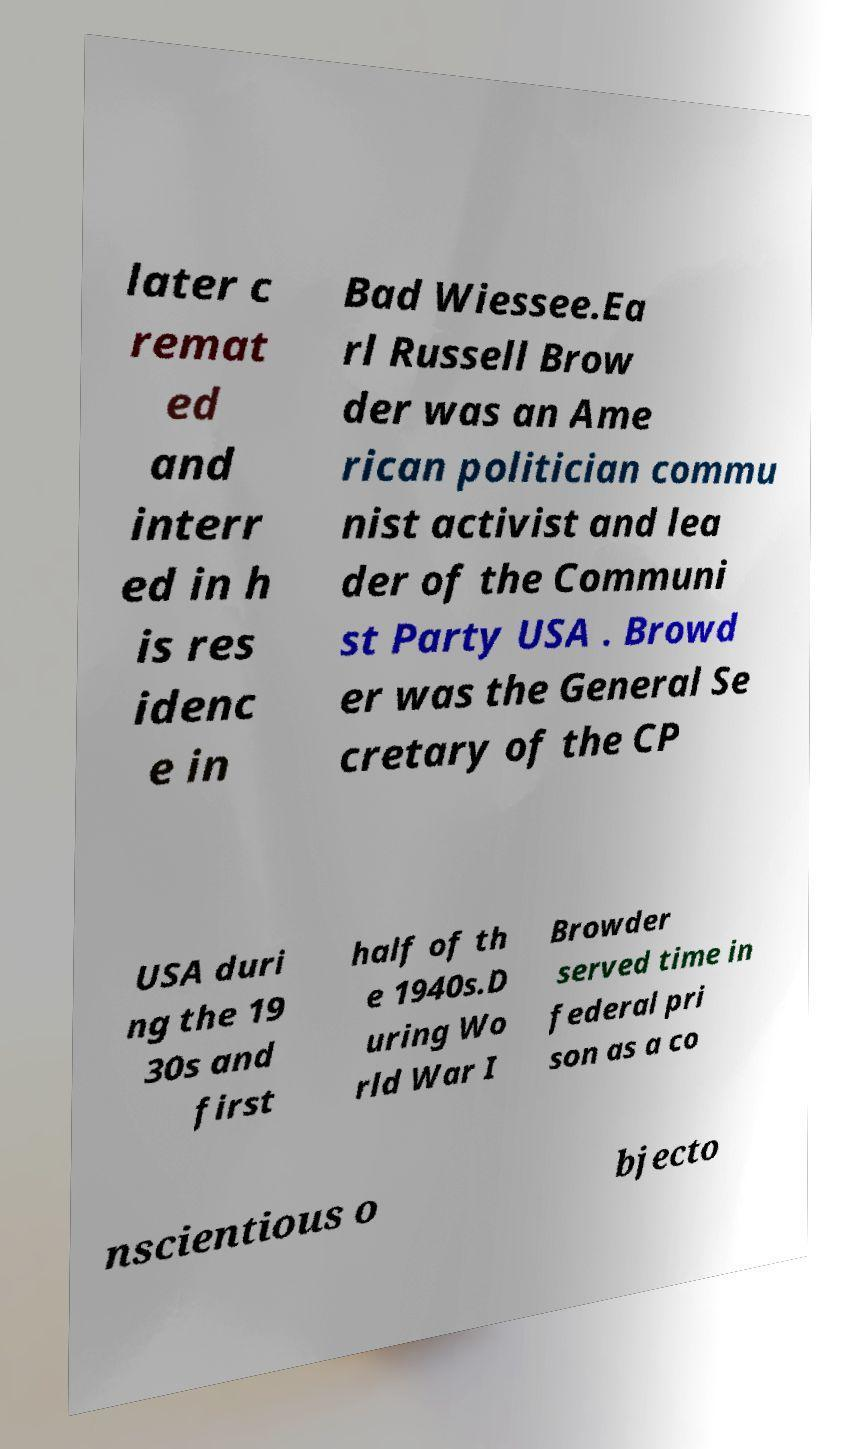Please read and relay the text visible in this image. What does it say? later c remat ed and interr ed in h is res idenc e in Bad Wiessee.Ea rl Russell Brow der was an Ame rican politician commu nist activist and lea der of the Communi st Party USA . Browd er was the General Se cretary of the CP USA duri ng the 19 30s and first half of th e 1940s.D uring Wo rld War I Browder served time in federal pri son as a co nscientious o bjecto 